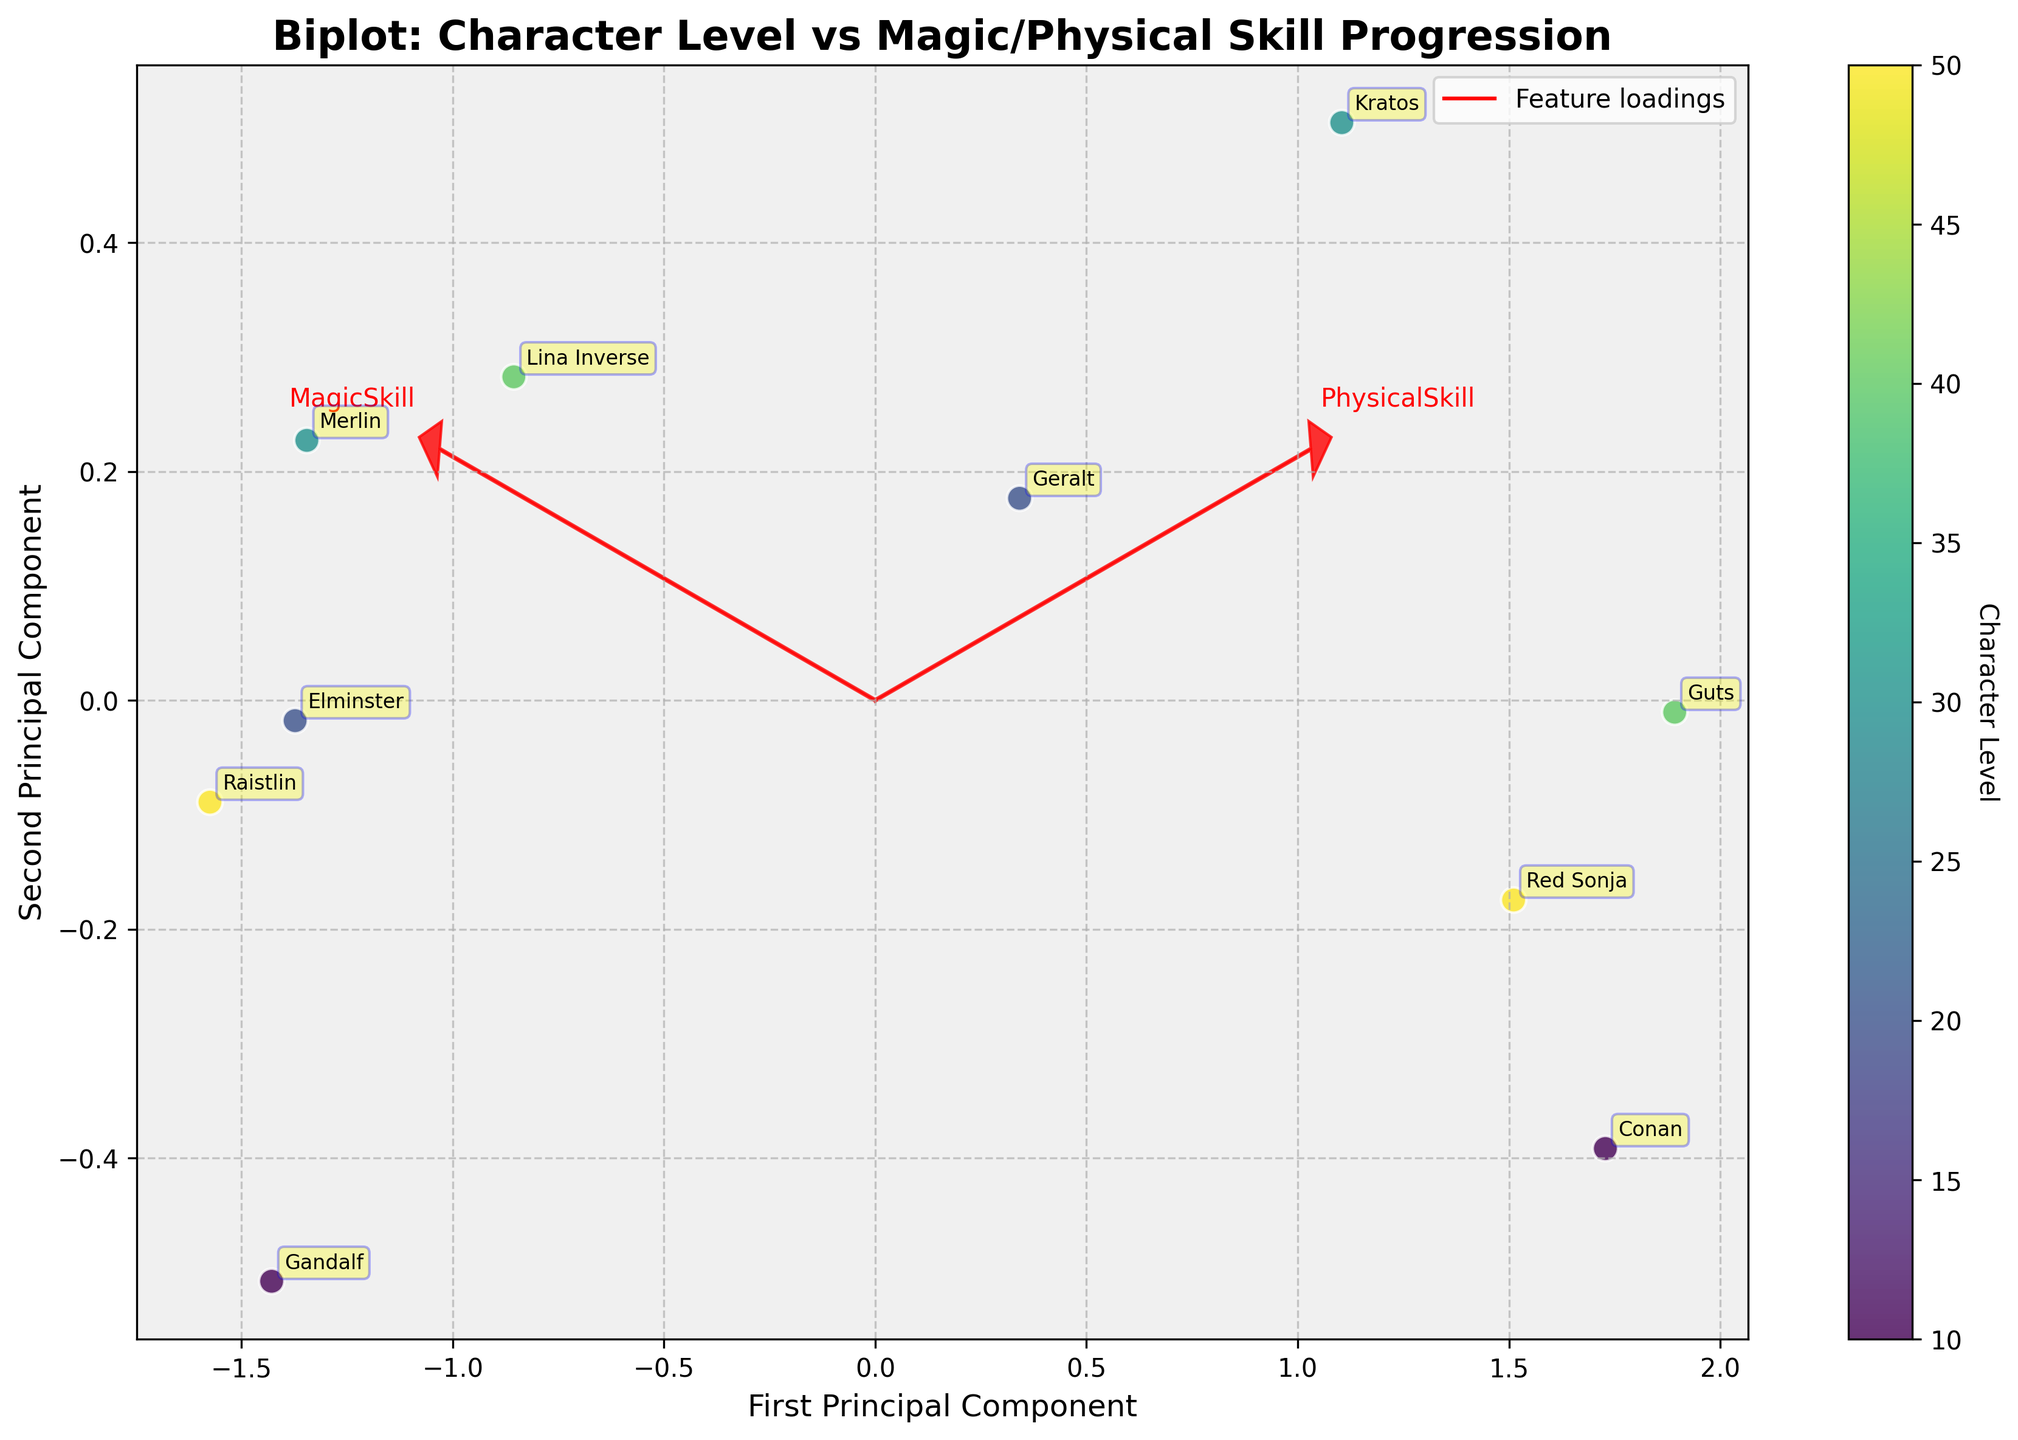Which character has the highest MagicSkill? By looking at the plot, we can see that Merlin has the highest MagicSkill, which is represented by an annotation on the plot.
Answer: Merlin Which character has a lower MagicSkill but a higher PhysicalSkill compared to Gandalf? By locating Gandalf's annotation and comparing other characters, we see that Kratos has a lower MagicSkill and a higher PhysicalSkill.
Answer: Kratos What is the overall trend of character levels in relation to magic and physical skills? Observing the color gradient from lighter to darker which represents the character level, we notice that higher-level characters tend to have higher values in either MagicSkill or PhysicalSkill but rarely in both.
Answer: Higher levels, high one type of skill How many characters are plotted in total? Counting the number of individual points/annotations on the plot gives us the total number of characters.
Answer: 10 Which skill has a stronger loading projection on the first principal component? By examining the length of the arrows corresponding to the loadings, we see that the MagicSkill arrow is longer along the first principal component axis.
Answer: MagicSkill Do characters with similar levels cluster together in the plot? Observing the scatterplot, characters with similar levels do tend to cluster together; for instance, characters at level 10 and level 20 are somewhat together.
Answer: Yes Which character has a balanced skill set in terms of Magic and Physical abilities? By analyzing the plot and looking for characters positioned towards the middle, we notice that Geralt has a balanced MagicSkill and PhysicalSkill.
Answer: Geralt What could be inferred from the position of Raistlin on the plot? Raistlin is far to the right along the MagicSkill axis and somewhat lower on PhysicalSkill, suggesting a character specializing in magic with lesser physical abilities.
Answer: Magic specialization, low physical abilities Which characters are at level 50? The color gradient representing the levels indicates that Raistlin and Red Sonja are at level 50, based on their position and color.
Answer: Raistlin and Red Sonja How do the vectors (loadings) help in understanding the skill impacts? The arrows show the direction and magnitude of the MagicSkill and PhysicalSkill, indicating how these skills are projected onto the principal components and contribute to character variability.
Answer: They show direction and magnitude of skill impacts 